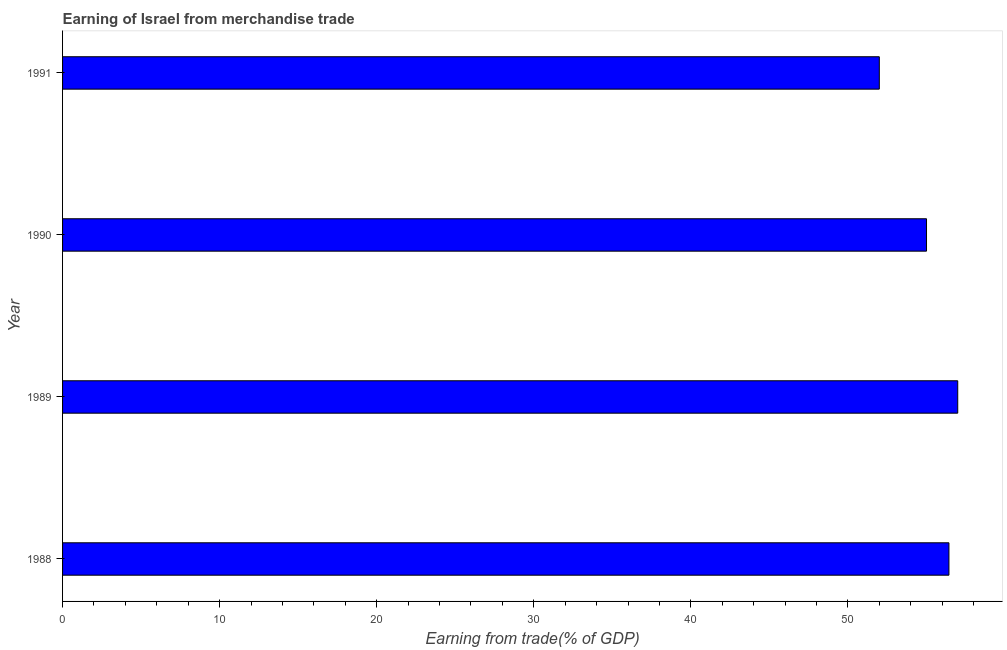Does the graph contain grids?
Make the answer very short. No. What is the title of the graph?
Offer a very short reply. Earning of Israel from merchandise trade. What is the label or title of the X-axis?
Offer a terse response. Earning from trade(% of GDP). What is the earning from merchandise trade in 1990?
Make the answer very short. 55.01. Across all years, what is the maximum earning from merchandise trade?
Provide a succinct answer. 56.99. Across all years, what is the minimum earning from merchandise trade?
Ensure brevity in your answer.  52. What is the sum of the earning from merchandise trade?
Give a very brief answer. 220.43. What is the difference between the earning from merchandise trade in 1989 and 1990?
Your response must be concise. 1.99. What is the average earning from merchandise trade per year?
Keep it short and to the point. 55.11. What is the median earning from merchandise trade?
Your answer should be compact. 55.72. Do a majority of the years between 1988 and 1989 (inclusive) have earning from merchandise trade greater than 46 %?
Your answer should be compact. Yes. Is the earning from merchandise trade in 1990 less than that in 1991?
Provide a short and direct response. No. What is the difference between the highest and the second highest earning from merchandise trade?
Your response must be concise. 0.56. Is the sum of the earning from merchandise trade in 1988 and 1990 greater than the maximum earning from merchandise trade across all years?
Keep it short and to the point. Yes. What is the difference between the highest and the lowest earning from merchandise trade?
Your response must be concise. 4.99. In how many years, is the earning from merchandise trade greater than the average earning from merchandise trade taken over all years?
Your response must be concise. 2. Are all the bars in the graph horizontal?
Your answer should be compact. Yes. What is the Earning from trade(% of GDP) of 1988?
Your answer should be compact. 56.43. What is the Earning from trade(% of GDP) in 1989?
Offer a very short reply. 56.99. What is the Earning from trade(% of GDP) in 1990?
Your answer should be very brief. 55.01. What is the Earning from trade(% of GDP) in 1991?
Keep it short and to the point. 52. What is the difference between the Earning from trade(% of GDP) in 1988 and 1989?
Give a very brief answer. -0.56. What is the difference between the Earning from trade(% of GDP) in 1988 and 1990?
Ensure brevity in your answer.  1.43. What is the difference between the Earning from trade(% of GDP) in 1988 and 1991?
Provide a short and direct response. 4.43. What is the difference between the Earning from trade(% of GDP) in 1989 and 1990?
Offer a very short reply. 1.99. What is the difference between the Earning from trade(% of GDP) in 1989 and 1991?
Your answer should be compact. 4.99. What is the difference between the Earning from trade(% of GDP) in 1990 and 1991?
Offer a very short reply. 3.01. What is the ratio of the Earning from trade(% of GDP) in 1988 to that in 1991?
Your response must be concise. 1.08. What is the ratio of the Earning from trade(% of GDP) in 1989 to that in 1990?
Keep it short and to the point. 1.04. What is the ratio of the Earning from trade(% of GDP) in 1989 to that in 1991?
Ensure brevity in your answer.  1.1. What is the ratio of the Earning from trade(% of GDP) in 1990 to that in 1991?
Your answer should be very brief. 1.06. 